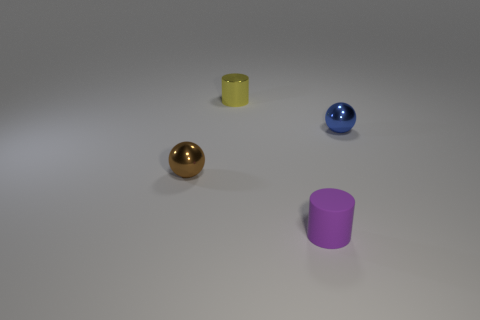Add 3 tiny yellow metallic cylinders. How many objects exist? 7 Add 4 small rubber things. How many small rubber things are left? 5 Add 2 small blue metal balls. How many small blue metal balls exist? 3 Subtract 0 green spheres. How many objects are left? 4 Subtract all tiny blue spheres. Subtract all tiny metal objects. How many objects are left? 0 